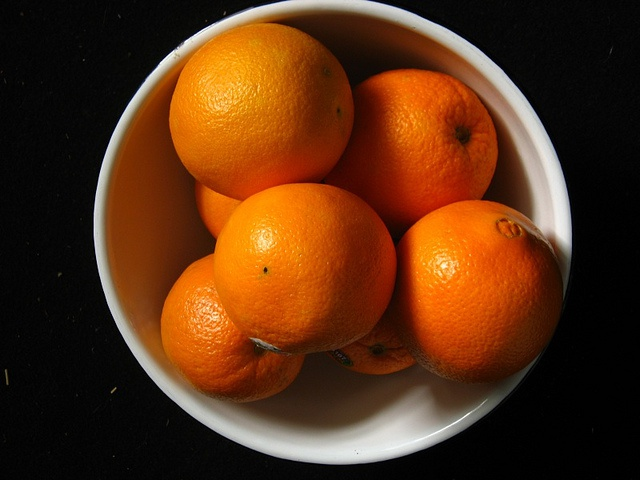Describe the objects in this image and their specific colors. I can see bowl in black, maroon, and red tones, orange in black, orange, and maroon tones, orange in black, red, maroon, and brown tones, orange in black, red, maroon, and orange tones, and orange in black, maroon, and red tones in this image. 